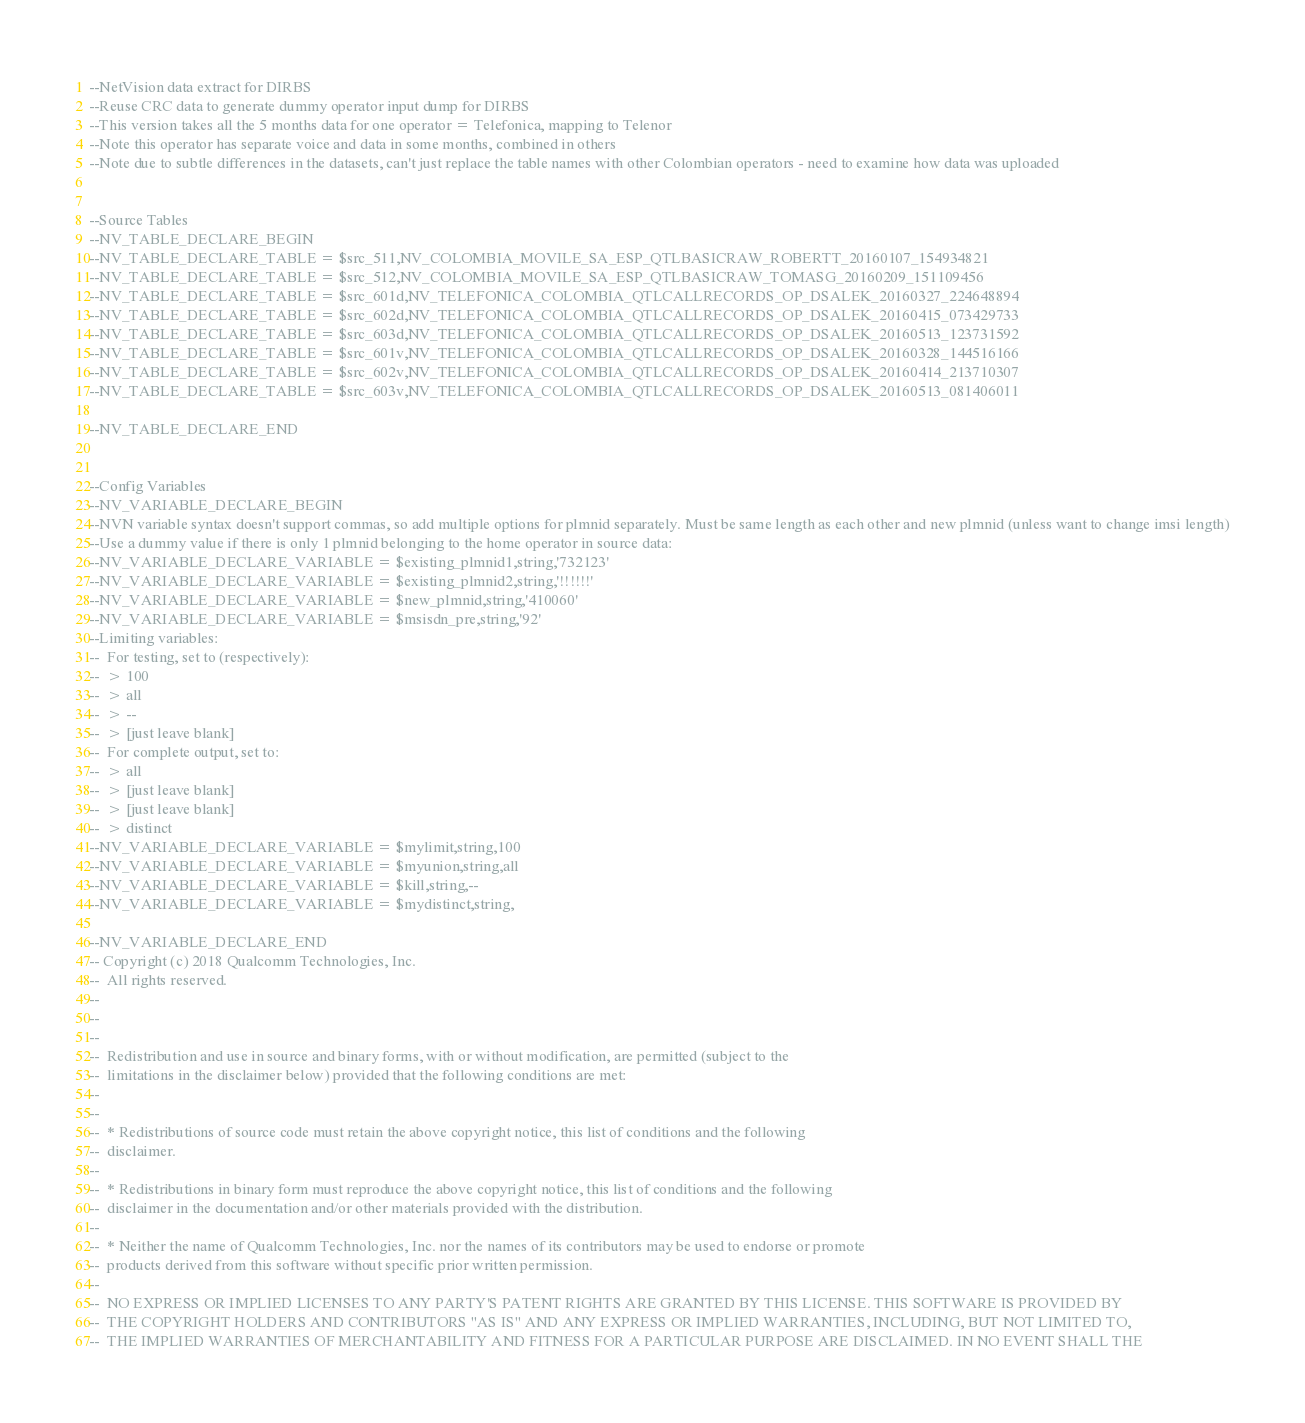<code> <loc_0><loc_0><loc_500><loc_500><_SQL_>--NetVision data extract for DIRBS
--Reuse CRC data to generate dummy operator input dump for DIRBS
--This version takes all the 5 months data for one operator = Telefonica, mapping to Telenor
--Note this operator has separate voice and data in some months, combined in others
--Note due to subtle differences in the datasets, can't just replace the table names with other Colombian operators - need to examine how data was uploaded


--Source Tables 
--NV_TABLE_DECLARE_BEGIN
--NV_TABLE_DECLARE_TABLE = $src_511,NV_COLOMBIA_MOVILE_SA_ESP_QTLBASICRAW_ROBERTT_20160107_154934821
--NV_TABLE_DECLARE_TABLE = $src_512,NV_COLOMBIA_MOVILE_SA_ESP_QTLBASICRAW_TOMASG_20160209_151109456
--NV_TABLE_DECLARE_TABLE = $src_601d,NV_TELEFONICA_COLOMBIA_QTLCALLRECORDS_OP_DSALEK_20160327_224648894
--NV_TABLE_DECLARE_TABLE = $src_602d,NV_TELEFONICA_COLOMBIA_QTLCALLRECORDS_OP_DSALEK_20160415_073429733
--NV_TABLE_DECLARE_TABLE = $src_603d,NV_TELEFONICA_COLOMBIA_QTLCALLRECORDS_OP_DSALEK_20160513_123731592
--NV_TABLE_DECLARE_TABLE = $src_601v,NV_TELEFONICA_COLOMBIA_QTLCALLRECORDS_OP_DSALEK_20160328_144516166
--NV_TABLE_DECLARE_TABLE = $src_602v,NV_TELEFONICA_COLOMBIA_QTLCALLRECORDS_OP_DSALEK_20160414_213710307
--NV_TABLE_DECLARE_TABLE = $src_603v,NV_TELEFONICA_COLOMBIA_QTLCALLRECORDS_OP_DSALEK_20160513_081406011

--NV_TABLE_DECLARE_END


--Config Variables
--NV_VARIABLE_DECLARE_BEGIN
--NVN variable syntax doesn't support commas, so add multiple options for plmnid separately. Must be same length as each other and new plmnid (unless want to change imsi length)
--Use a dummy value if there is only 1 plmnid belonging to the home operator in source data:
--NV_VARIABLE_DECLARE_VARIABLE = $existing_plmnid1,string,'732123'
--NV_VARIABLE_DECLARE_VARIABLE = $existing_plmnid2,string,'!!!!!!'
--NV_VARIABLE_DECLARE_VARIABLE = $new_plmnid,string,'410060'
--NV_VARIABLE_DECLARE_VARIABLE = $msisdn_pre,string,'92'
--Limiting variables:
--  For testing, set to (respectively):
--  > 100
--  > all
--  > --
--  > [just leave blank]
--  For complete output, set to:
--  > all
--  > [just leave blank]
--  > [just leave blank]
--  > distinct
--NV_VARIABLE_DECLARE_VARIABLE = $mylimit,string,100
--NV_VARIABLE_DECLARE_VARIABLE = $myunion,string,all
--NV_VARIABLE_DECLARE_VARIABLE = $kill,string,--
--NV_VARIABLE_DECLARE_VARIABLE = $mydistinct,string,

--NV_VARIABLE_DECLARE_END
-- Copyright (c) 2018 Qualcomm Technologies, Inc.
--  All rights reserved.
--
--
--
--  Redistribution and use in source and binary forms, with or without modification, are permitted (subject to the
--  limitations in the disclaimer below) provided that the following conditions are met:
--
--
--  * Redistributions of source code must retain the above copyright notice, this list of conditions and the following
--  disclaimer.
--
--  * Redistributions in binary form must reproduce the above copyright notice, this list of conditions and the following
--  disclaimer in the documentation and/or other materials provided with the distribution.
--
--  * Neither the name of Qualcomm Technologies, Inc. nor the names of its contributors may be used to endorse or promote
--  products derived from this software without specific prior written permission.
--
--  NO EXPRESS OR IMPLIED LICENSES TO ANY PARTY'S PATENT RIGHTS ARE GRANTED BY THIS LICENSE. THIS SOFTWARE IS PROVIDED BY
--  THE COPYRIGHT HOLDERS AND CONTRIBUTORS "AS IS" AND ANY EXPRESS OR IMPLIED WARRANTIES, INCLUDING, BUT NOT LIMITED TO,
--  THE IMPLIED WARRANTIES OF MERCHANTABILITY AND FITNESS FOR A PARTICULAR PURPOSE ARE DISCLAIMED. IN NO EVENT SHALL THE</code> 